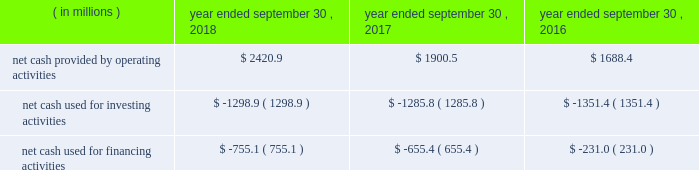Compared to earlier levels .
The pre-tax non-cash impairments of certain mineral rights and real estate discussed above under the caption fffdland and development impairments fffd are not included in segment income .
Liquidity and capital resources on january 29 , 2018 , we announced that a definitive agreement had been signed for us to acquire all of the outstanding shares of kapstone for $ 35.00 per share and the assumption of approximately $ 1.36 billion in net debt , for a total enterprise value of approximately $ 4.9 billion .
In contemplation of the transaction , on march 6 , 2018 , we issued $ 600.0 million aggregate principal amount of 3.75% ( 3.75 % ) senior notes due 2025 and $ 600.0 million aggregate principal amount of 4.0% ( 4.0 % ) senior notes due 2028 in an unregistered offering pursuant to rule 144a and regulation s under the securities act of 1933 , as amended ( the fffdsecurities act fffd ) .
In addition , on march 7 , 2018 , we entered into the delayed draw credit facilities ( as hereinafter defined ) that provide for $ 3.8 billion of senior unsecured term loans .
On november 2 , 2018 , in connection with the closing of the kapstone acquisition , we drew upon the facility in full .
The proceeds of the delayed draw credit facilities ( as hereinafter defined ) and other sources of cash were used to pay the consideration for the kapstone acquisition , to repay certain existing indebtedness of kapstone and to pay fees and expenses incurred in connection with the kapstone acquisition .
We fund our working capital requirements , capital expenditures , mergers , acquisitions and investments , restructuring activities , dividends and stock repurchases from net cash provided by operating activities , borrowings under our credit facilities , proceeds from our new a/r sales agreement ( as hereinafter defined ) , proceeds from the sale of property , plant and equipment removed from service and proceeds received in connection with the issuance of debt and equity securities .
See fffdnote 13 .
Debt fffdtt of the notes to consolidated financial statements for additional information .
Funding for our domestic operations in the foreseeable future is expected to come from sources of liquidity within our domestic operations , including cash and cash equivalents , and available borrowings under our credit facilities .
As such , our foreign cash and cash equivalents are not expected to be a key source of liquidity to our domestic operations .
At september 30 , 2018 , excluding the delayed draw credit facilities , we had approximately $ 3.2 billion of availability under our committed credit facilities , primarily under our revolving credit facility , the majority of which matures on july 1 , 2022 .
This liquidity may be used to provide for ongoing working capital needs and for other general corporate purposes , including acquisitions , dividends and stock repurchases .
Certain restrictive covenants govern our maximum availability under the credit facilities .
We test and report our compliance with these covenants as required and we were in compliance with all of these covenants at september 30 , 2018 .
At september 30 , 2018 , we had $ 104.9 million of outstanding letters of credit not drawn cash and cash equivalents were $ 636.8 million at september 30 , 2018 and $ 298.1 million at september 30 , 2017 .
We used a significant portion of the cash and cash equivalents on hand at september 30 , 2018 in connection with the closing of the kapstone acquisition .
Approximately 20% ( 20 % ) of the cash and cash equivalents at september 30 , 2018 were held outside of the u.s .
At september 30 , 2018 , total debt was $ 6415.2 million , $ 740.7 million of which was current .
At september 30 , 2017 , total debt was $ 6554.8 million , $ 608.7 million of which was current .
Cash flow activityy .
Net cash provided by operating activities during fiscal 2018 increased $ 520.4 million from fiscal 2017 primarily due to higher cash earnings and lower cash taxes due to the impact of the tax act .
Net cash provided by operating activities during fiscal 2017 increased $ 212.1 million from fiscal 2016 primarily due to a $ 111.6 million net increase in cash flow from working capital changes plus higher after-tax cash proceeds from our land and development segment fffds accelerated monetization .
The changes in working capital in fiscal 2018 , 2017 and 2016 included a .
In 2018 what was the net change in the cash in millions? 
Computations: ((2420.9 + -1298.9) + -755.1)
Answer: 366.9. 